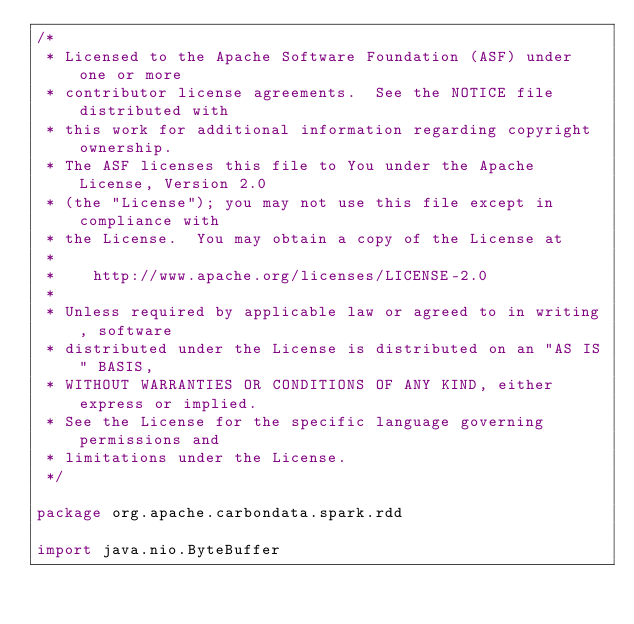Convert code to text. <code><loc_0><loc_0><loc_500><loc_500><_Scala_>/*
 * Licensed to the Apache Software Foundation (ASF) under one or more
 * contributor license agreements.  See the NOTICE file distributed with
 * this work for additional information regarding copyright ownership.
 * The ASF licenses this file to You under the Apache License, Version 2.0
 * (the "License"); you may not use this file except in compliance with
 * the License.  You may obtain a copy of the License at
 *
 *    http://www.apache.org/licenses/LICENSE-2.0
 *
 * Unless required by applicable law or agreed to in writing, software
 * distributed under the License is distributed on an "AS IS" BASIS,
 * WITHOUT WARRANTIES OR CONDITIONS OF ANY KIND, either express or implied.
 * See the License for the specific language governing permissions and
 * limitations under the License.
 */

package org.apache.carbondata.spark.rdd

import java.nio.ByteBuffer</code> 